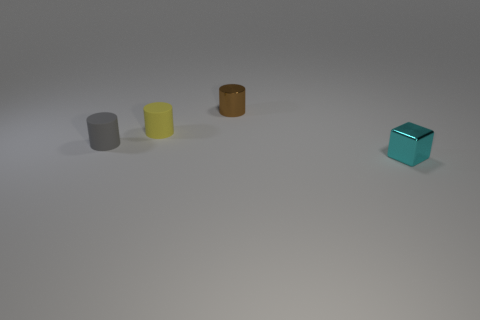Are any matte cubes visible?
Your answer should be very brief. No. What is the shape of the small shiny object to the left of the tiny metal object that is on the right side of the shiny thing to the left of the small cyan shiny object?
Offer a terse response. Cylinder. There is a tiny shiny block; what number of metallic things are on the left side of it?
Ensure brevity in your answer.  1. Is the material of the tiny cylinder on the left side of the tiny yellow thing the same as the yellow object?
Ensure brevity in your answer.  Yes. What number of other things are there of the same shape as the small cyan object?
Provide a succinct answer. 0. How many small cylinders are on the left side of the shiny object behind the metal thing that is to the right of the tiny brown cylinder?
Keep it short and to the point. 2. There is a object to the right of the brown cylinder; what is its color?
Ensure brevity in your answer.  Cyan. The other matte object that is the same shape as the tiny gray object is what size?
Your response must be concise. Small. What material is the yellow thing that is to the left of the metal thing that is behind the small metallic thing that is in front of the metallic cylinder?
Ensure brevity in your answer.  Rubber. Is the number of small yellow rubber things on the left side of the tiny block greater than the number of yellow objects that are in front of the tiny yellow object?
Provide a short and direct response. Yes. 